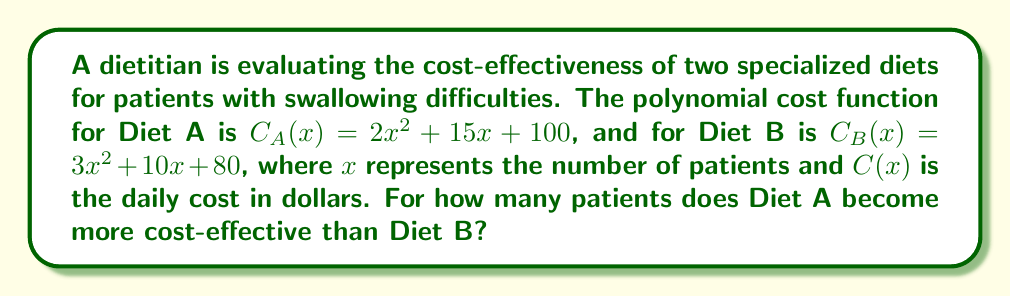What is the answer to this math problem? To determine when Diet A becomes more cost-effective than Diet B, we need to find the point where the cost of Diet A becomes less than the cost of Diet B. This occurs when:

$$C_A(x) < C_B(x)$$

Substituting the given polynomial functions:

$$(2x^2 + 15x + 100) < (3x^2 + 10x + 80)$$

To find the point where they're equal, we set up the equation:

$$(2x^2 + 15x + 100) = (3x^2 + 10x + 80)$$

Subtracting the left side from both sides:

$$0 = x^2 - 5x - 20$$

This is a quadratic equation. We can solve it using the quadratic formula:

$$x = \frac{-b \pm \sqrt{b^2 - 4ac}}{2a}$$

Where $a=1$, $b=-5$, and $c=-20$

$$x = \frac{5 \pm \sqrt{25 + 80}}{2} = \frac{5 \pm \sqrt{105}}{2}$$

This gives us two solutions:

$$x_1 = \frac{5 + \sqrt{105}}{2} \approx 7.62$$
$$x_2 = \frac{5 - \sqrt{105}}{2} \approx -2.62$$

Since we're dealing with number of patients, we can discard the negative solution. The positive solution tells us that Diet A becomes cheaper than Diet B when there are more than 7.62 patients.

As we're dealing with whole numbers of patients, Diet A becomes more cost-effective starting from 8 patients.
Answer: Diet A becomes more cost-effective than Diet B when there are 8 or more patients. 